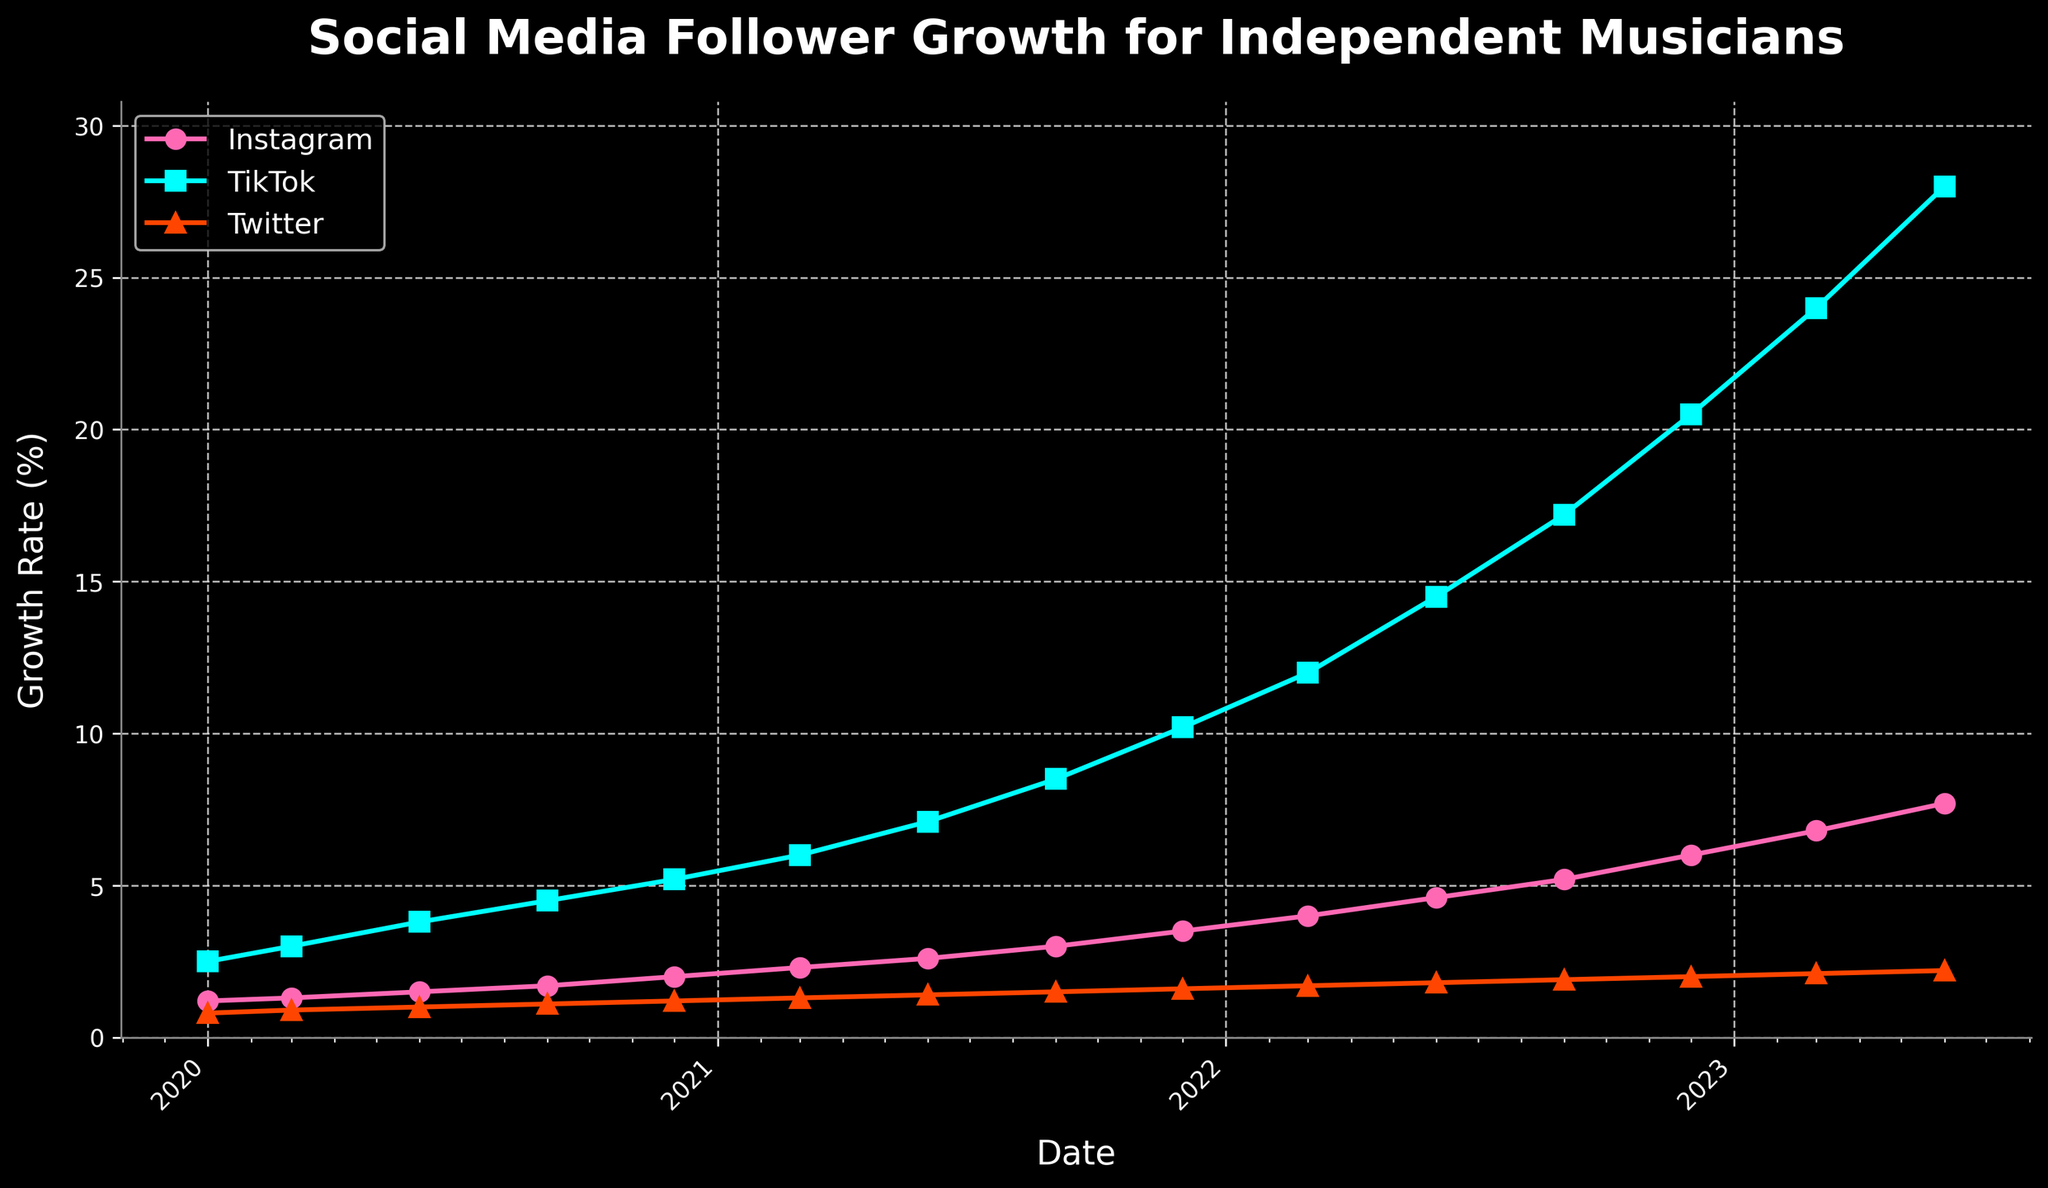what is the growth rate of TikTok at the start of 2021? Identify the point corresponding to 2021, January, and look at TikTok. The value is 6.0%.
Answer: 6.0% Which platform showed the highest growth rate in June 2021? Compare the growth rates for all three platforms in June 2021. TikTok at 7.1% is the highest among Instagram (2.6%) and Twitter (1.4%).
Answer: TikTok Describe the trends observed in Instagram and Twitter growth rates from 2020 to 2023. Both Instagram and Twitter show a steady upward trend, with Instagram growing at a slightly faster rate than Twitter. Instagram starts at 1.2% and reaches 7.7%, while Twitter starts at 0.8% and ends at 2.2%.
Answer: Steady upward trends, Instagram is faster In December 2022, how does TikTok's growth rate compare to Instagram's growth rate? Look at December 2022 and compare the TikTok growth rate (20.5%) to Instagram's (6.0%).
Answer: TikTok's is much higher Which platform had the smallest growth rate increase from September to December 2022? Calculate the difference for each platform between September and December 2022. Instagram increases by 0.8% (6.0 - 5.2), TikTok by 3.3% (20.5 - 17.2), and Twitter by 0.1% (2.0 - 1.9). Twitter has the smallest increase.
Answer: Twitter By how much did TikTok's growth rate increase between June 2022 and June 2023? Subtract the June 2022 value for TikTok (14.5%) from the June 2023 value (28.0%) to find the increase, which is 13.5%.
Answer: 13.5% What is the average growth rate of Instagram over the entire period? Sum all the Instagram values and divide by the number of data points (1.2 + 1.3 + 1.5 + 1.7 + 2.0 + 2.3 + 2.6 + 3.0 + 3.5 + 4.0 + 4.6 + 5.2 + 6.0 + 6.8 + 7.7) = 53.4. Divide by 15.
Answer: 3.56% Between March 2020 and March 2023, which platform experienced the highest percentage increase in growth rate? Calculate the percentage increase for each platform: TikTok's increase is (24.0-2.5)/2.5 = 860%, Instagram's increase is (6.8-1.2)/1.2 = 466.67%, Twitter's increase is (2.1-0.8)/0.8 = 162.5%.
Answer: TikTok What can be inferred about the popularity of TikTok among musicians compared to Instagram and Twitter over the three years? Notice the steeper growth curve for TikTok and its higher final value, suggesting exponentially growing popularity relative to Instagram and Twitter.
Answer: TikTok is more popular How does the follower growth trend of all three platforms appear visually? All three lines show upward trends, with TikTok having the steepest rise, followed by Instagram and then Twitter.
Answer: TikTok steepest, Instagram second, Twitter slowest 